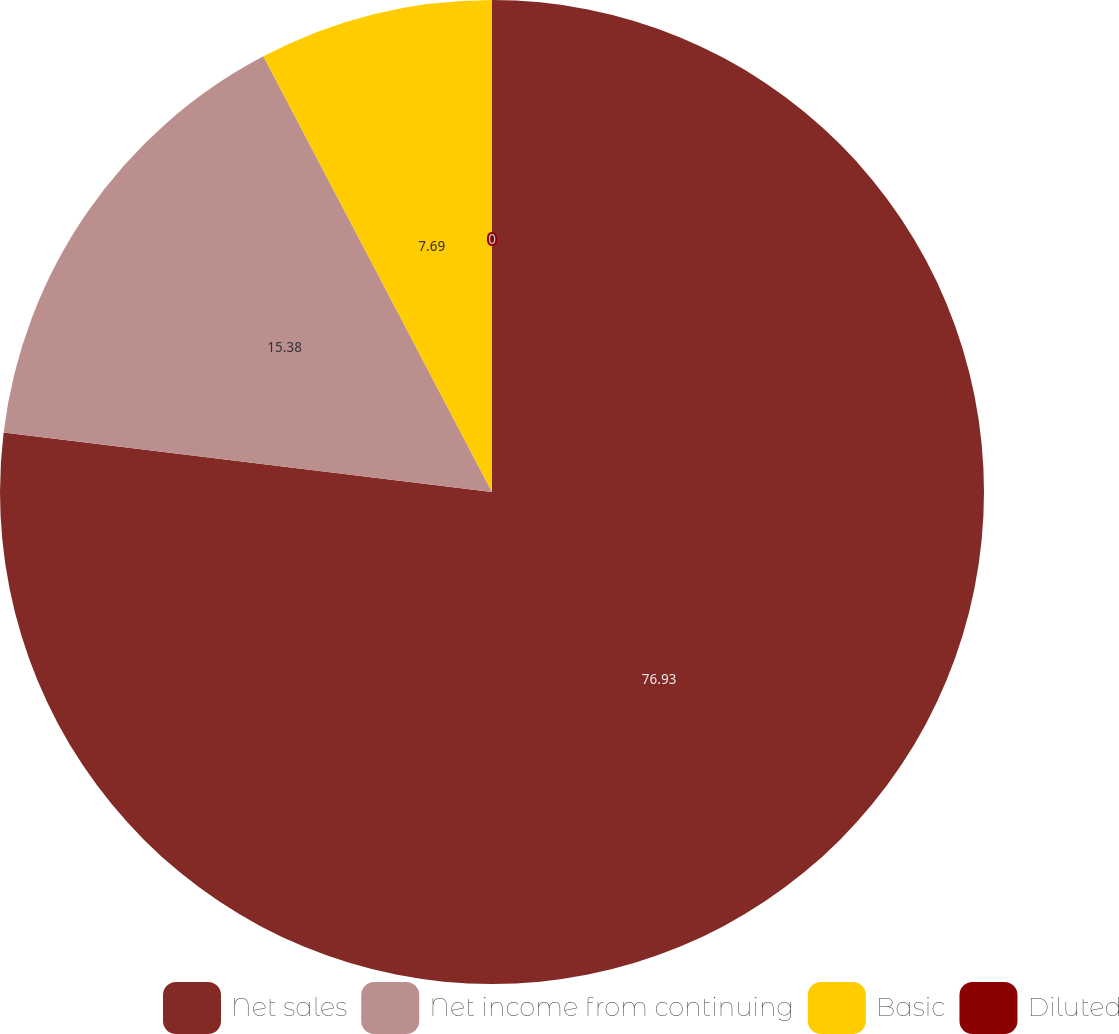<chart> <loc_0><loc_0><loc_500><loc_500><pie_chart><fcel>Net sales<fcel>Net income from continuing<fcel>Basic<fcel>Diluted<nl><fcel>76.92%<fcel>15.38%<fcel>7.69%<fcel>0.0%<nl></chart> 